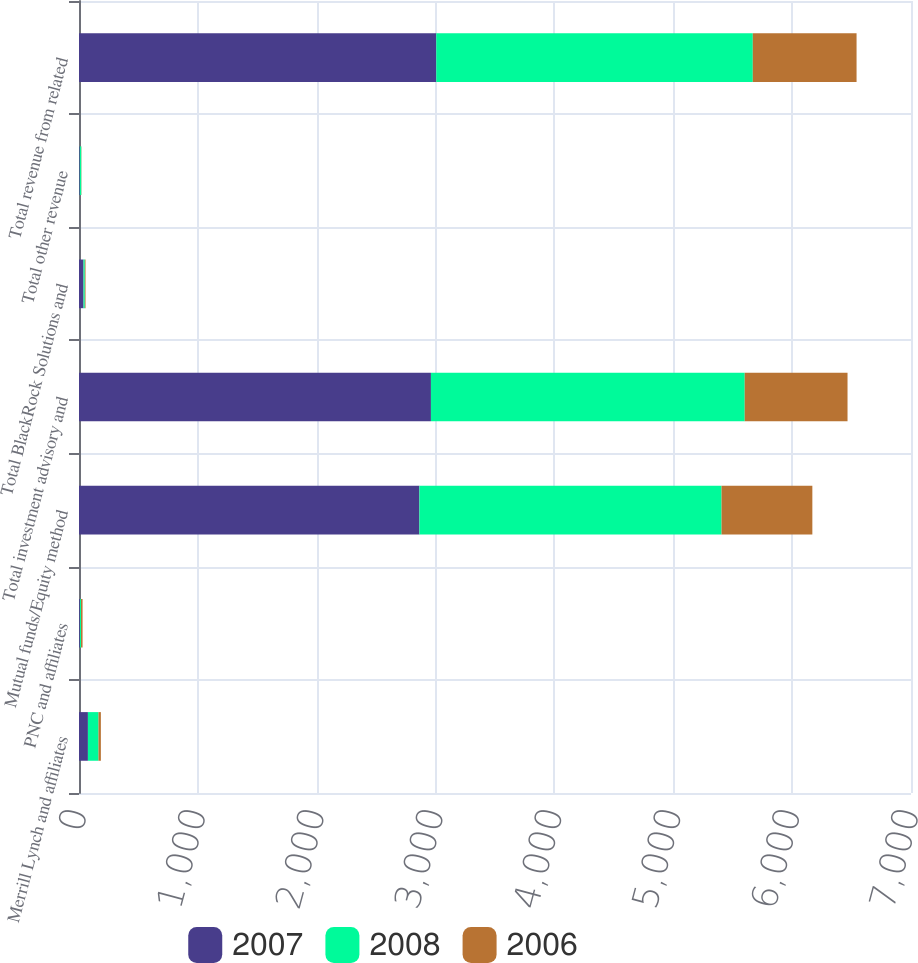Convert chart. <chart><loc_0><loc_0><loc_500><loc_500><stacked_bar_chart><ecel><fcel>Merrill Lynch and affiliates<fcel>PNC and affiliates<fcel>Mutual funds/Equity method<fcel>Total investment advisory and<fcel>Total BlackRock Solutions and<fcel>Total other revenue<fcel>Total revenue from related<nl><fcel>2007<fcel>75<fcel>8<fcel>2864<fcel>2961<fcel>38<fcel>7<fcel>3006<nl><fcel>2008<fcel>89<fcel>9<fcel>2542<fcel>2640<fcel>11<fcel>12<fcel>2663<nl><fcel>2006<fcel>20<fcel>13<fcel>764<fcel>865<fcel>6<fcel>2<fcel>873<nl></chart> 